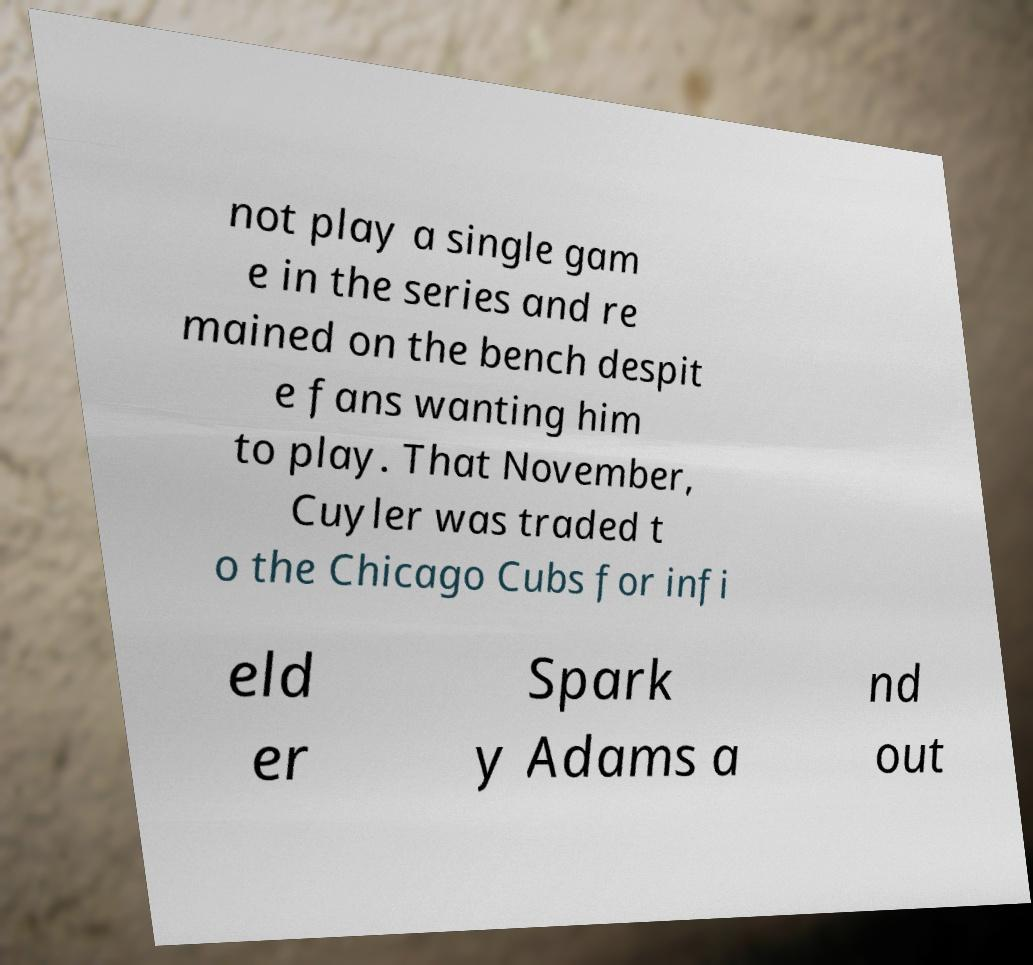I need the written content from this picture converted into text. Can you do that? not play a single gam e in the series and re mained on the bench despit e fans wanting him to play. That November, Cuyler was traded t o the Chicago Cubs for infi eld er Spark y Adams a nd out 